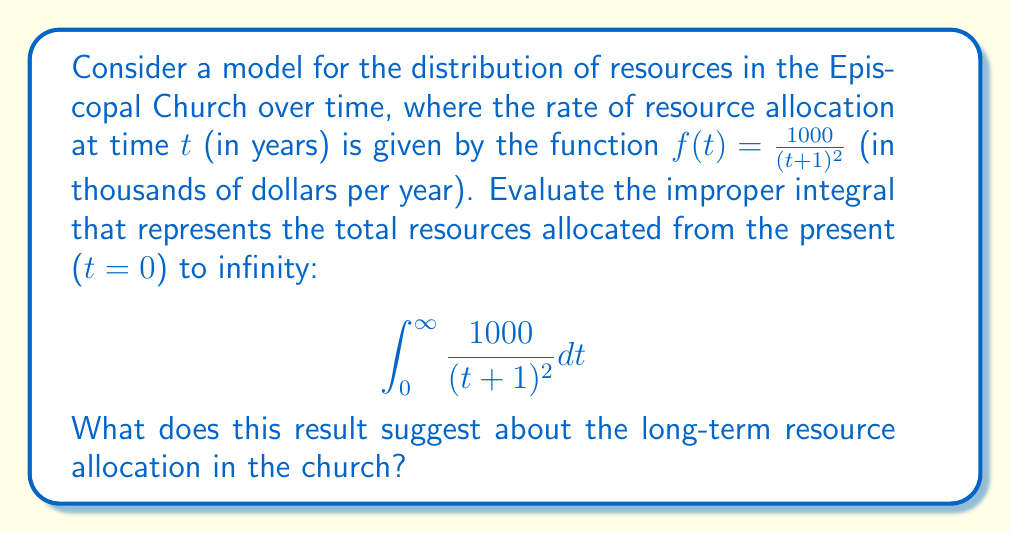Provide a solution to this math problem. To evaluate this improper integral, we can follow these steps:

1) First, let's set up a definite integral with a limit:

   $$\lim_{b \to \infty} \int_0^b \frac{1000}{(t+1)^2} dt$$

2) We can solve this using u-substitution. Let $u = t+1$, then $du = dt$. When $t = 0$, $u = 1$, and when $t = b$, $u = b+1$. The integral becomes:

   $$\lim_{b \to \infty} \int_1^{b+1} \frac{1000}{u^2} du$$

3) Now we can integrate:

   $$\lim_{b \to \infty} \left[-\frac{1000}{u}\right]_1^{b+1}$$

4) Evaluating the antiderivative:

   $$\lim_{b \to \infty} \left(-\frac{1000}{b+1} + 1000\right)$$

5) As $b$ approaches infinity, $\frac{1000}{b+1}$ approaches 0, so:

   $$\lim_{b \to \infty} (0 + 1000) = 1000$$

Therefore, the improper integral evaluates to 1000.

This result suggests that the total resources allocated by the church from the present to infinity is finite and equal to 1000 thousand dollars, or 1 million dollars. This implies that while the church continues to allocate resources indefinitely, the total amount is bounded. The rate of allocation decreases rapidly over time, leading to a convergent total.
Answer: The improper integral evaluates to 1000, representing 1 million dollars in total resources allocated over an infinite time period. 